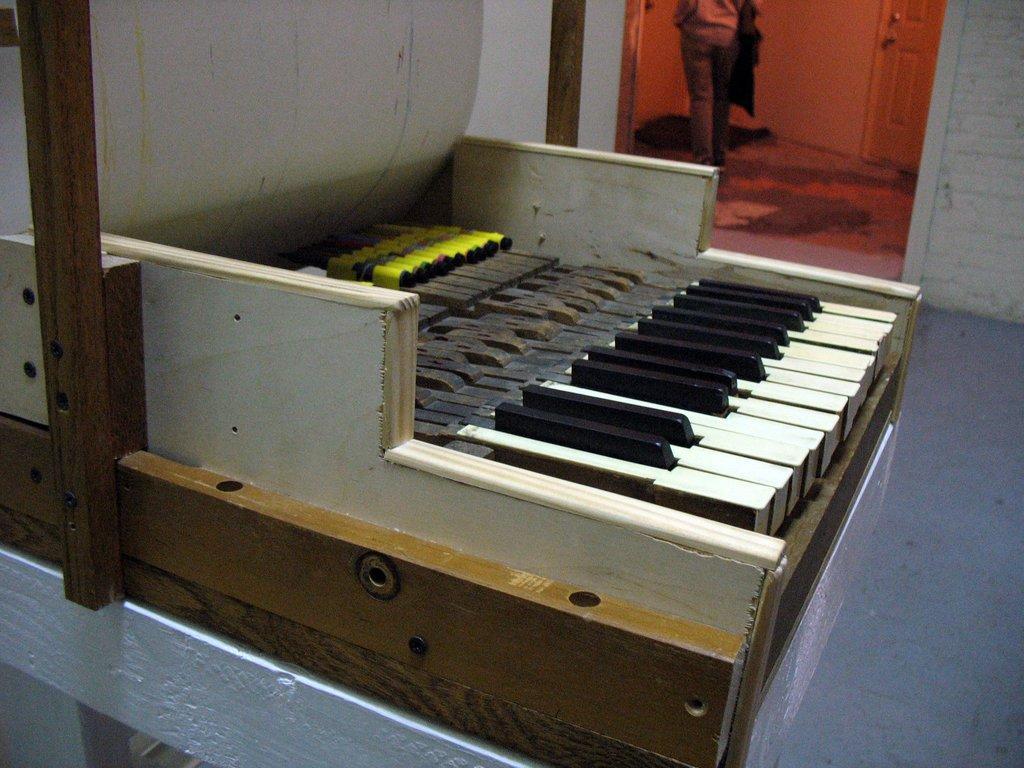Can you describe this image briefly? This picture is clicked inside the room. Here is a musical instrument which looks like keyboard. On background, we see another room in which we see a person standing in that room. Behind the man, we see a wall and a door. 